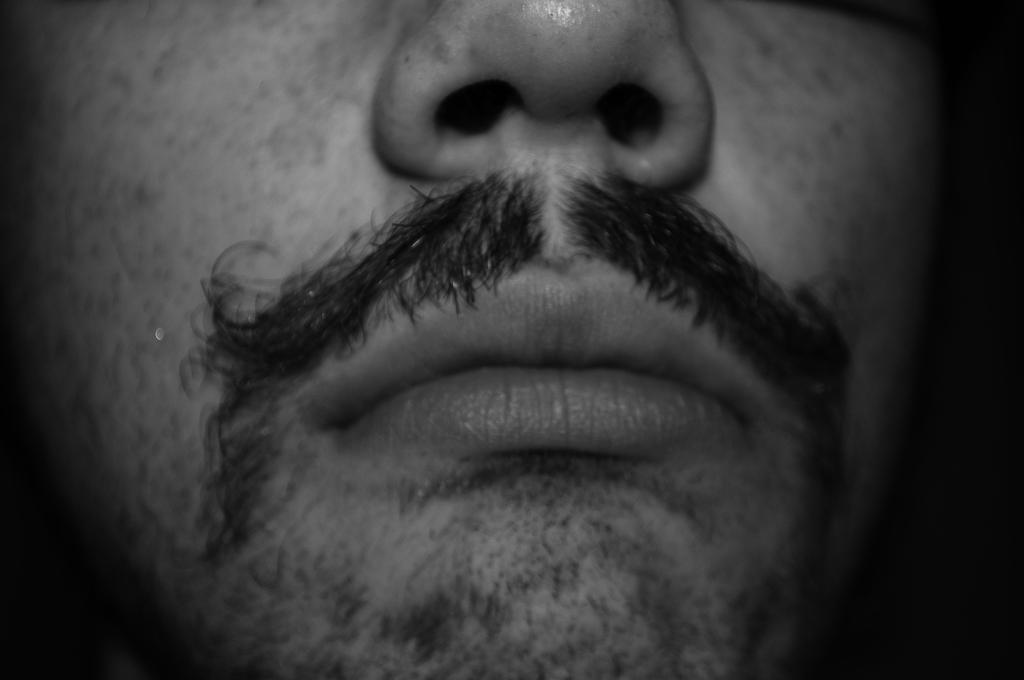What facial features are visible in the image? The image contains a man's mouth and nose. What is the color scheme of the image? The image is black and white in color. What type of hook can be seen hanging from the man's nose in the image? There is no hook present in the image; it only contains a man's mouth and nose. 